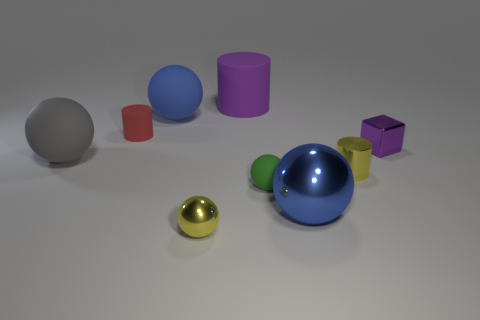There is a rubber thing that is in front of the tiny cylinder that is in front of the small metal thing that is behind the large gray matte sphere; what is its size? The rubber item in question appears to be a small, green ball, similar in size to the tiny cylinder and the small metal object nearby. It is notably smaller than the large gray matte sphere that it rests behind. 